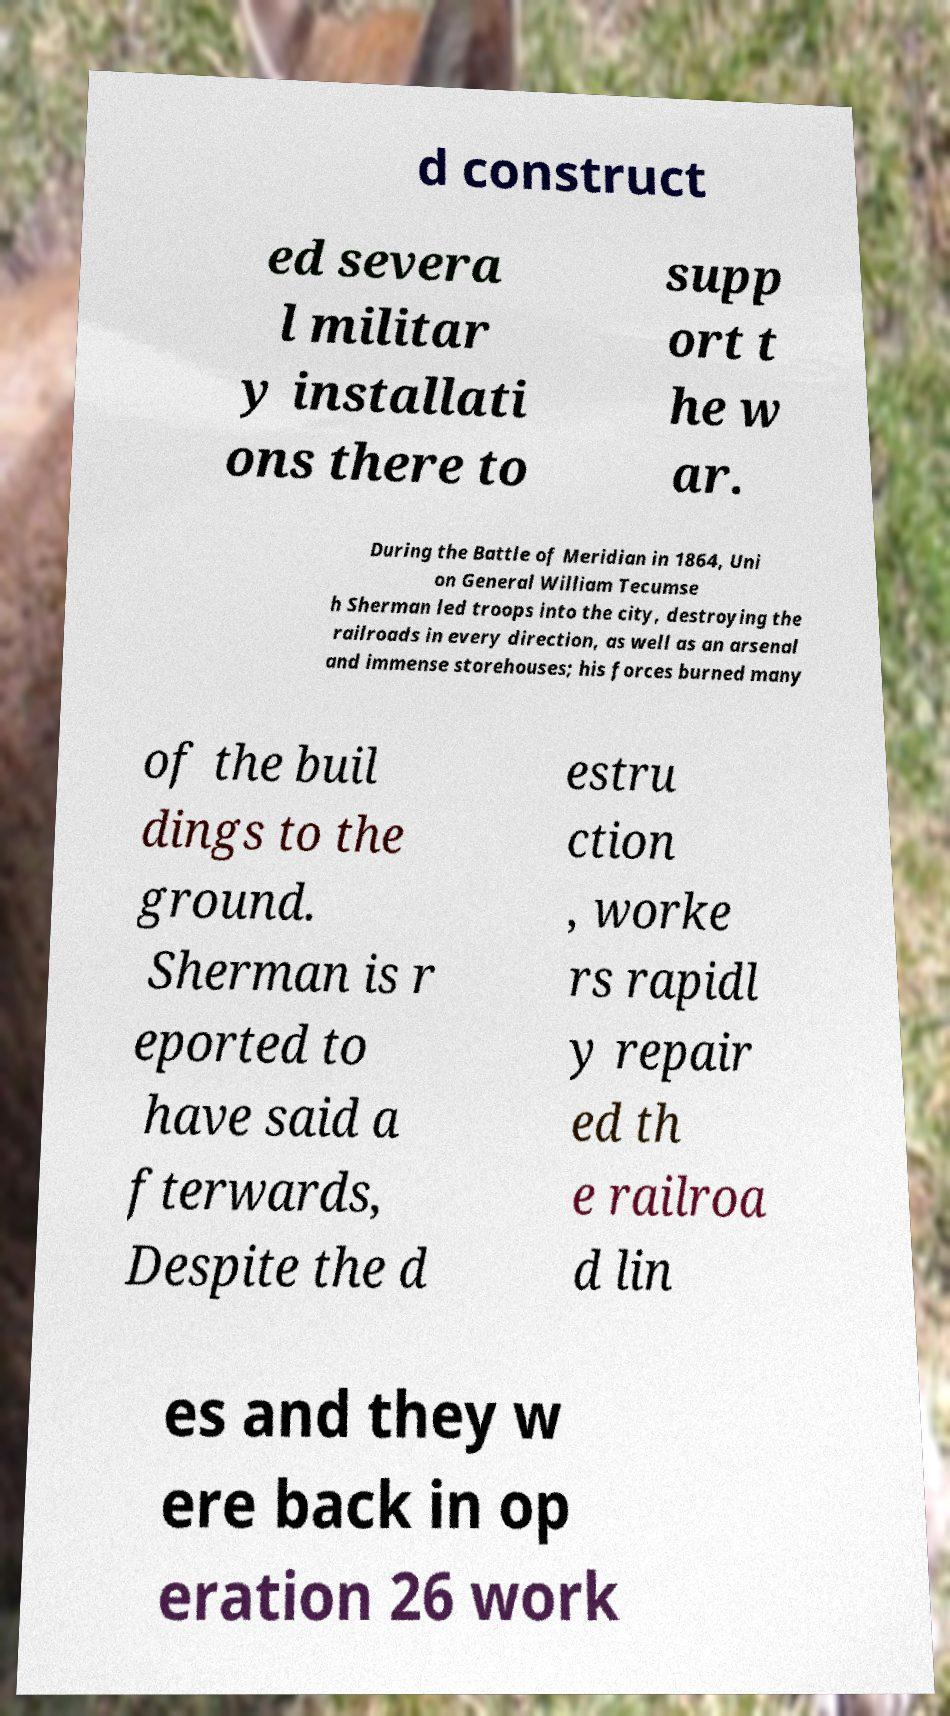I need the written content from this picture converted into text. Can you do that? d construct ed severa l militar y installati ons there to supp ort t he w ar. During the Battle of Meridian in 1864, Uni on General William Tecumse h Sherman led troops into the city, destroying the railroads in every direction, as well as an arsenal and immense storehouses; his forces burned many of the buil dings to the ground. Sherman is r eported to have said a fterwards, Despite the d estru ction , worke rs rapidl y repair ed th e railroa d lin es and they w ere back in op eration 26 work 